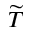Convert formula to latex. <formula><loc_0><loc_0><loc_500><loc_500>\widetilde { T }</formula> 